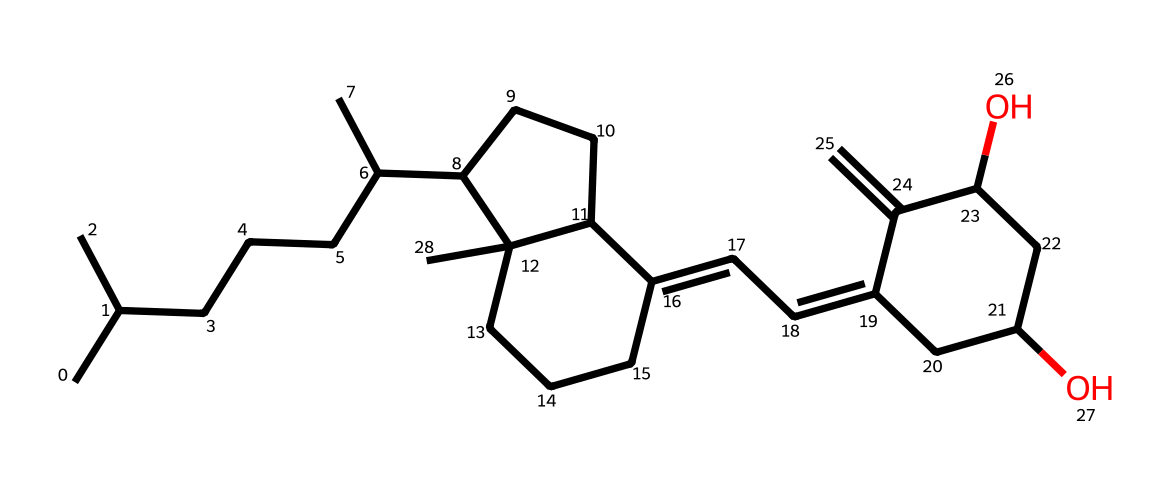what is the molecular formula of vitamin D3? To determine the molecular formula, we count the number of carbon (C), hydrogen (H), and oxygen (O) atoms in the SMILES representation. In the structure, there are 27 carbon atoms, 44 hydrogen atoms, and 2 oxygen atoms. Thus, the molecular formula is C27H44O2.
Answer: C27H44O2 how many rings are present in the structure of vitamin D3? By examining the chemical structure, we can identify that there are two distinct ring systems present in the molecule. One is a cycloalkane ring, and the other is a cyclohexene. Hence, the total number of rings is two.
Answer: 2 what types of geometric isomers can vitamin D3 have? Vitamin D3 can exhibit cis and trans geometric isomerism due to the presence of double bonds in its cyclic structure. The arrangement around the double bonds will determine the type of isomer.
Answer: cis and trans how many double bonds are present in the structure? Analyzing the structure for double bonds, we find three double bonds within the entire molecular framework. Each double bond affects the geometric configuration of vitamin D3.
Answer: 3 how does the structure of vitamin D3 relate to its biological function? The molecular structure, including the presence of hydroxyl groups and double bonds, is crucial for vitamin D3's activity and function in regulating calcium and phosphate metabolism in the body, improving bone health. The arrangement allows for proper binding to vitamin D receptors.
Answer: binding to receptors 